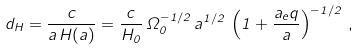Convert formula to latex. <formula><loc_0><loc_0><loc_500><loc_500>d _ { H } = \frac { c } { a \, H ( a ) } = \frac { c } { H _ { 0 } } \, \Omega _ { 0 } ^ { - 1 / 2 } \, a ^ { 1 / 2 } \, \left ( 1 + \frac { a _ { e } q } { a } \right ) ^ { - 1 / 2 } \, ,</formula> 